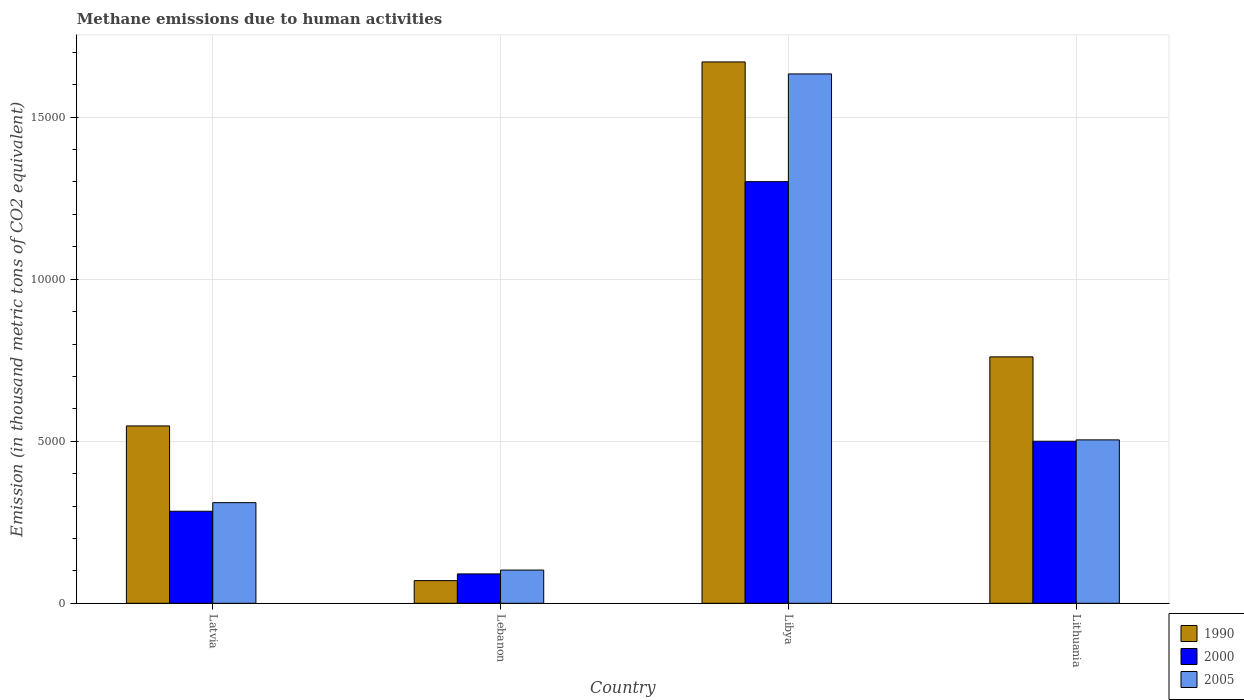Are the number of bars on each tick of the X-axis equal?
Your answer should be compact. Yes. How many bars are there on the 4th tick from the left?
Make the answer very short. 3. What is the label of the 4th group of bars from the left?
Keep it short and to the point. Lithuania. What is the amount of methane emitted in 2000 in Lebanon?
Your answer should be very brief. 906.6. Across all countries, what is the maximum amount of methane emitted in 2005?
Provide a short and direct response. 1.63e+04. Across all countries, what is the minimum amount of methane emitted in 2005?
Offer a very short reply. 1024.8. In which country was the amount of methane emitted in 2005 maximum?
Offer a terse response. Libya. In which country was the amount of methane emitted in 1990 minimum?
Ensure brevity in your answer.  Lebanon. What is the total amount of methane emitted in 1990 in the graph?
Ensure brevity in your answer.  3.05e+04. What is the difference between the amount of methane emitted in 2005 in Lebanon and that in Libya?
Give a very brief answer. -1.53e+04. What is the difference between the amount of methane emitted in 2000 in Lebanon and the amount of methane emitted in 1990 in Lithuania?
Offer a very short reply. -6697. What is the average amount of methane emitted in 1990 per country?
Offer a terse response. 7619.95. What is the difference between the amount of methane emitted of/in 2000 and amount of methane emitted of/in 2005 in Libya?
Offer a terse response. -3323.2. In how many countries, is the amount of methane emitted in 2000 greater than 3000 thousand metric tons?
Keep it short and to the point. 2. What is the ratio of the amount of methane emitted in 2000 in Latvia to that in Lithuania?
Ensure brevity in your answer.  0.57. Is the difference between the amount of methane emitted in 2000 in Libya and Lithuania greater than the difference between the amount of methane emitted in 2005 in Libya and Lithuania?
Provide a succinct answer. No. What is the difference between the highest and the second highest amount of methane emitted in 2005?
Offer a very short reply. -1937.2. What is the difference between the highest and the lowest amount of methane emitted in 1990?
Your response must be concise. 1.60e+04. In how many countries, is the amount of methane emitted in 2005 greater than the average amount of methane emitted in 2005 taken over all countries?
Keep it short and to the point. 1. Is the sum of the amount of methane emitted in 2005 in Latvia and Lithuania greater than the maximum amount of methane emitted in 2000 across all countries?
Make the answer very short. No. What does the 1st bar from the left in Lebanon represents?
Keep it short and to the point. 1990. What does the 3rd bar from the right in Latvia represents?
Your answer should be very brief. 1990. Is it the case that in every country, the sum of the amount of methane emitted in 1990 and amount of methane emitted in 2000 is greater than the amount of methane emitted in 2005?
Offer a terse response. Yes. Are all the bars in the graph horizontal?
Your response must be concise. No. What is the difference between two consecutive major ticks on the Y-axis?
Keep it short and to the point. 5000. Does the graph contain any zero values?
Your response must be concise. No. Where does the legend appear in the graph?
Your response must be concise. Bottom right. What is the title of the graph?
Your response must be concise. Methane emissions due to human activities. What is the label or title of the X-axis?
Give a very brief answer. Country. What is the label or title of the Y-axis?
Provide a succinct answer. Emission (in thousand metric tons of CO2 equivalent). What is the Emission (in thousand metric tons of CO2 equivalent) in 1990 in Latvia?
Keep it short and to the point. 5472.8. What is the Emission (in thousand metric tons of CO2 equivalent) in 2000 in Latvia?
Provide a short and direct response. 2840. What is the Emission (in thousand metric tons of CO2 equivalent) in 2005 in Latvia?
Give a very brief answer. 3105. What is the Emission (in thousand metric tons of CO2 equivalent) in 1990 in Lebanon?
Keep it short and to the point. 699. What is the Emission (in thousand metric tons of CO2 equivalent) in 2000 in Lebanon?
Ensure brevity in your answer.  906.6. What is the Emission (in thousand metric tons of CO2 equivalent) in 2005 in Lebanon?
Keep it short and to the point. 1024.8. What is the Emission (in thousand metric tons of CO2 equivalent) of 1990 in Libya?
Your answer should be very brief. 1.67e+04. What is the Emission (in thousand metric tons of CO2 equivalent) in 2000 in Libya?
Your response must be concise. 1.30e+04. What is the Emission (in thousand metric tons of CO2 equivalent) in 2005 in Libya?
Provide a succinct answer. 1.63e+04. What is the Emission (in thousand metric tons of CO2 equivalent) of 1990 in Lithuania?
Your response must be concise. 7603.6. What is the Emission (in thousand metric tons of CO2 equivalent) of 2000 in Lithuania?
Provide a succinct answer. 5000.2. What is the Emission (in thousand metric tons of CO2 equivalent) in 2005 in Lithuania?
Offer a very short reply. 5042.2. Across all countries, what is the maximum Emission (in thousand metric tons of CO2 equivalent) in 1990?
Make the answer very short. 1.67e+04. Across all countries, what is the maximum Emission (in thousand metric tons of CO2 equivalent) of 2000?
Provide a short and direct response. 1.30e+04. Across all countries, what is the maximum Emission (in thousand metric tons of CO2 equivalent) in 2005?
Keep it short and to the point. 1.63e+04. Across all countries, what is the minimum Emission (in thousand metric tons of CO2 equivalent) of 1990?
Offer a terse response. 699. Across all countries, what is the minimum Emission (in thousand metric tons of CO2 equivalent) in 2000?
Your response must be concise. 906.6. Across all countries, what is the minimum Emission (in thousand metric tons of CO2 equivalent) of 2005?
Your answer should be very brief. 1024.8. What is the total Emission (in thousand metric tons of CO2 equivalent) of 1990 in the graph?
Your answer should be compact. 3.05e+04. What is the total Emission (in thousand metric tons of CO2 equivalent) in 2000 in the graph?
Offer a terse response. 2.18e+04. What is the total Emission (in thousand metric tons of CO2 equivalent) in 2005 in the graph?
Offer a very short reply. 2.55e+04. What is the difference between the Emission (in thousand metric tons of CO2 equivalent) in 1990 in Latvia and that in Lebanon?
Keep it short and to the point. 4773.8. What is the difference between the Emission (in thousand metric tons of CO2 equivalent) in 2000 in Latvia and that in Lebanon?
Provide a short and direct response. 1933.4. What is the difference between the Emission (in thousand metric tons of CO2 equivalent) of 2005 in Latvia and that in Lebanon?
Ensure brevity in your answer.  2080.2. What is the difference between the Emission (in thousand metric tons of CO2 equivalent) of 1990 in Latvia and that in Libya?
Your answer should be very brief. -1.12e+04. What is the difference between the Emission (in thousand metric tons of CO2 equivalent) of 2000 in Latvia and that in Libya?
Ensure brevity in your answer.  -1.02e+04. What is the difference between the Emission (in thousand metric tons of CO2 equivalent) in 2005 in Latvia and that in Libya?
Your answer should be compact. -1.32e+04. What is the difference between the Emission (in thousand metric tons of CO2 equivalent) of 1990 in Latvia and that in Lithuania?
Your answer should be very brief. -2130.8. What is the difference between the Emission (in thousand metric tons of CO2 equivalent) in 2000 in Latvia and that in Lithuania?
Keep it short and to the point. -2160.2. What is the difference between the Emission (in thousand metric tons of CO2 equivalent) in 2005 in Latvia and that in Lithuania?
Your response must be concise. -1937.2. What is the difference between the Emission (in thousand metric tons of CO2 equivalent) in 1990 in Lebanon and that in Libya?
Give a very brief answer. -1.60e+04. What is the difference between the Emission (in thousand metric tons of CO2 equivalent) in 2000 in Lebanon and that in Libya?
Your answer should be compact. -1.21e+04. What is the difference between the Emission (in thousand metric tons of CO2 equivalent) in 2005 in Lebanon and that in Libya?
Keep it short and to the point. -1.53e+04. What is the difference between the Emission (in thousand metric tons of CO2 equivalent) in 1990 in Lebanon and that in Lithuania?
Make the answer very short. -6904.6. What is the difference between the Emission (in thousand metric tons of CO2 equivalent) in 2000 in Lebanon and that in Lithuania?
Your answer should be compact. -4093.6. What is the difference between the Emission (in thousand metric tons of CO2 equivalent) in 2005 in Lebanon and that in Lithuania?
Provide a succinct answer. -4017.4. What is the difference between the Emission (in thousand metric tons of CO2 equivalent) of 1990 in Libya and that in Lithuania?
Provide a short and direct response. 9100.8. What is the difference between the Emission (in thousand metric tons of CO2 equivalent) of 2000 in Libya and that in Lithuania?
Ensure brevity in your answer.  8010.9. What is the difference between the Emission (in thousand metric tons of CO2 equivalent) of 2005 in Libya and that in Lithuania?
Provide a short and direct response. 1.13e+04. What is the difference between the Emission (in thousand metric tons of CO2 equivalent) of 1990 in Latvia and the Emission (in thousand metric tons of CO2 equivalent) of 2000 in Lebanon?
Ensure brevity in your answer.  4566.2. What is the difference between the Emission (in thousand metric tons of CO2 equivalent) of 1990 in Latvia and the Emission (in thousand metric tons of CO2 equivalent) of 2005 in Lebanon?
Your answer should be compact. 4448. What is the difference between the Emission (in thousand metric tons of CO2 equivalent) of 2000 in Latvia and the Emission (in thousand metric tons of CO2 equivalent) of 2005 in Lebanon?
Provide a short and direct response. 1815.2. What is the difference between the Emission (in thousand metric tons of CO2 equivalent) of 1990 in Latvia and the Emission (in thousand metric tons of CO2 equivalent) of 2000 in Libya?
Make the answer very short. -7538.3. What is the difference between the Emission (in thousand metric tons of CO2 equivalent) of 1990 in Latvia and the Emission (in thousand metric tons of CO2 equivalent) of 2005 in Libya?
Offer a terse response. -1.09e+04. What is the difference between the Emission (in thousand metric tons of CO2 equivalent) of 2000 in Latvia and the Emission (in thousand metric tons of CO2 equivalent) of 2005 in Libya?
Provide a succinct answer. -1.35e+04. What is the difference between the Emission (in thousand metric tons of CO2 equivalent) in 1990 in Latvia and the Emission (in thousand metric tons of CO2 equivalent) in 2000 in Lithuania?
Your answer should be compact. 472.6. What is the difference between the Emission (in thousand metric tons of CO2 equivalent) of 1990 in Latvia and the Emission (in thousand metric tons of CO2 equivalent) of 2005 in Lithuania?
Keep it short and to the point. 430.6. What is the difference between the Emission (in thousand metric tons of CO2 equivalent) in 2000 in Latvia and the Emission (in thousand metric tons of CO2 equivalent) in 2005 in Lithuania?
Provide a short and direct response. -2202.2. What is the difference between the Emission (in thousand metric tons of CO2 equivalent) in 1990 in Lebanon and the Emission (in thousand metric tons of CO2 equivalent) in 2000 in Libya?
Make the answer very short. -1.23e+04. What is the difference between the Emission (in thousand metric tons of CO2 equivalent) of 1990 in Lebanon and the Emission (in thousand metric tons of CO2 equivalent) of 2005 in Libya?
Provide a succinct answer. -1.56e+04. What is the difference between the Emission (in thousand metric tons of CO2 equivalent) of 2000 in Lebanon and the Emission (in thousand metric tons of CO2 equivalent) of 2005 in Libya?
Your answer should be very brief. -1.54e+04. What is the difference between the Emission (in thousand metric tons of CO2 equivalent) in 1990 in Lebanon and the Emission (in thousand metric tons of CO2 equivalent) in 2000 in Lithuania?
Provide a succinct answer. -4301.2. What is the difference between the Emission (in thousand metric tons of CO2 equivalent) of 1990 in Lebanon and the Emission (in thousand metric tons of CO2 equivalent) of 2005 in Lithuania?
Ensure brevity in your answer.  -4343.2. What is the difference between the Emission (in thousand metric tons of CO2 equivalent) of 2000 in Lebanon and the Emission (in thousand metric tons of CO2 equivalent) of 2005 in Lithuania?
Ensure brevity in your answer.  -4135.6. What is the difference between the Emission (in thousand metric tons of CO2 equivalent) of 1990 in Libya and the Emission (in thousand metric tons of CO2 equivalent) of 2000 in Lithuania?
Your answer should be very brief. 1.17e+04. What is the difference between the Emission (in thousand metric tons of CO2 equivalent) in 1990 in Libya and the Emission (in thousand metric tons of CO2 equivalent) in 2005 in Lithuania?
Your answer should be very brief. 1.17e+04. What is the difference between the Emission (in thousand metric tons of CO2 equivalent) in 2000 in Libya and the Emission (in thousand metric tons of CO2 equivalent) in 2005 in Lithuania?
Your answer should be very brief. 7968.9. What is the average Emission (in thousand metric tons of CO2 equivalent) of 1990 per country?
Offer a terse response. 7619.95. What is the average Emission (in thousand metric tons of CO2 equivalent) in 2000 per country?
Make the answer very short. 5439.48. What is the average Emission (in thousand metric tons of CO2 equivalent) of 2005 per country?
Give a very brief answer. 6376.57. What is the difference between the Emission (in thousand metric tons of CO2 equivalent) in 1990 and Emission (in thousand metric tons of CO2 equivalent) in 2000 in Latvia?
Ensure brevity in your answer.  2632.8. What is the difference between the Emission (in thousand metric tons of CO2 equivalent) in 1990 and Emission (in thousand metric tons of CO2 equivalent) in 2005 in Latvia?
Provide a short and direct response. 2367.8. What is the difference between the Emission (in thousand metric tons of CO2 equivalent) of 2000 and Emission (in thousand metric tons of CO2 equivalent) of 2005 in Latvia?
Offer a very short reply. -265. What is the difference between the Emission (in thousand metric tons of CO2 equivalent) of 1990 and Emission (in thousand metric tons of CO2 equivalent) of 2000 in Lebanon?
Make the answer very short. -207.6. What is the difference between the Emission (in thousand metric tons of CO2 equivalent) of 1990 and Emission (in thousand metric tons of CO2 equivalent) of 2005 in Lebanon?
Make the answer very short. -325.8. What is the difference between the Emission (in thousand metric tons of CO2 equivalent) in 2000 and Emission (in thousand metric tons of CO2 equivalent) in 2005 in Lebanon?
Offer a very short reply. -118.2. What is the difference between the Emission (in thousand metric tons of CO2 equivalent) of 1990 and Emission (in thousand metric tons of CO2 equivalent) of 2000 in Libya?
Ensure brevity in your answer.  3693.3. What is the difference between the Emission (in thousand metric tons of CO2 equivalent) in 1990 and Emission (in thousand metric tons of CO2 equivalent) in 2005 in Libya?
Offer a terse response. 370.1. What is the difference between the Emission (in thousand metric tons of CO2 equivalent) of 2000 and Emission (in thousand metric tons of CO2 equivalent) of 2005 in Libya?
Offer a terse response. -3323.2. What is the difference between the Emission (in thousand metric tons of CO2 equivalent) in 1990 and Emission (in thousand metric tons of CO2 equivalent) in 2000 in Lithuania?
Ensure brevity in your answer.  2603.4. What is the difference between the Emission (in thousand metric tons of CO2 equivalent) of 1990 and Emission (in thousand metric tons of CO2 equivalent) of 2005 in Lithuania?
Provide a succinct answer. 2561.4. What is the difference between the Emission (in thousand metric tons of CO2 equivalent) in 2000 and Emission (in thousand metric tons of CO2 equivalent) in 2005 in Lithuania?
Keep it short and to the point. -42. What is the ratio of the Emission (in thousand metric tons of CO2 equivalent) of 1990 in Latvia to that in Lebanon?
Your answer should be compact. 7.83. What is the ratio of the Emission (in thousand metric tons of CO2 equivalent) of 2000 in Latvia to that in Lebanon?
Your answer should be compact. 3.13. What is the ratio of the Emission (in thousand metric tons of CO2 equivalent) in 2005 in Latvia to that in Lebanon?
Offer a terse response. 3.03. What is the ratio of the Emission (in thousand metric tons of CO2 equivalent) of 1990 in Latvia to that in Libya?
Make the answer very short. 0.33. What is the ratio of the Emission (in thousand metric tons of CO2 equivalent) in 2000 in Latvia to that in Libya?
Make the answer very short. 0.22. What is the ratio of the Emission (in thousand metric tons of CO2 equivalent) in 2005 in Latvia to that in Libya?
Your response must be concise. 0.19. What is the ratio of the Emission (in thousand metric tons of CO2 equivalent) in 1990 in Latvia to that in Lithuania?
Keep it short and to the point. 0.72. What is the ratio of the Emission (in thousand metric tons of CO2 equivalent) of 2000 in Latvia to that in Lithuania?
Offer a terse response. 0.57. What is the ratio of the Emission (in thousand metric tons of CO2 equivalent) in 2005 in Latvia to that in Lithuania?
Keep it short and to the point. 0.62. What is the ratio of the Emission (in thousand metric tons of CO2 equivalent) of 1990 in Lebanon to that in Libya?
Provide a short and direct response. 0.04. What is the ratio of the Emission (in thousand metric tons of CO2 equivalent) in 2000 in Lebanon to that in Libya?
Offer a very short reply. 0.07. What is the ratio of the Emission (in thousand metric tons of CO2 equivalent) of 2005 in Lebanon to that in Libya?
Your answer should be very brief. 0.06. What is the ratio of the Emission (in thousand metric tons of CO2 equivalent) of 1990 in Lebanon to that in Lithuania?
Your answer should be compact. 0.09. What is the ratio of the Emission (in thousand metric tons of CO2 equivalent) in 2000 in Lebanon to that in Lithuania?
Keep it short and to the point. 0.18. What is the ratio of the Emission (in thousand metric tons of CO2 equivalent) of 2005 in Lebanon to that in Lithuania?
Ensure brevity in your answer.  0.2. What is the ratio of the Emission (in thousand metric tons of CO2 equivalent) in 1990 in Libya to that in Lithuania?
Provide a short and direct response. 2.2. What is the ratio of the Emission (in thousand metric tons of CO2 equivalent) of 2000 in Libya to that in Lithuania?
Keep it short and to the point. 2.6. What is the ratio of the Emission (in thousand metric tons of CO2 equivalent) in 2005 in Libya to that in Lithuania?
Offer a terse response. 3.24. What is the difference between the highest and the second highest Emission (in thousand metric tons of CO2 equivalent) of 1990?
Your answer should be very brief. 9100.8. What is the difference between the highest and the second highest Emission (in thousand metric tons of CO2 equivalent) in 2000?
Your response must be concise. 8010.9. What is the difference between the highest and the second highest Emission (in thousand metric tons of CO2 equivalent) in 2005?
Offer a very short reply. 1.13e+04. What is the difference between the highest and the lowest Emission (in thousand metric tons of CO2 equivalent) in 1990?
Provide a succinct answer. 1.60e+04. What is the difference between the highest and the lowest Emission (in thousand metric tons of CO2 equivalent) in 2000?
Keep it short and to the point. 1.21e+04. What is the difference between the highest and the lowest Emission (in thousand metric tons of CO2 equivalent) in 2005?
Give a very brief answer. 1.53e+04. 